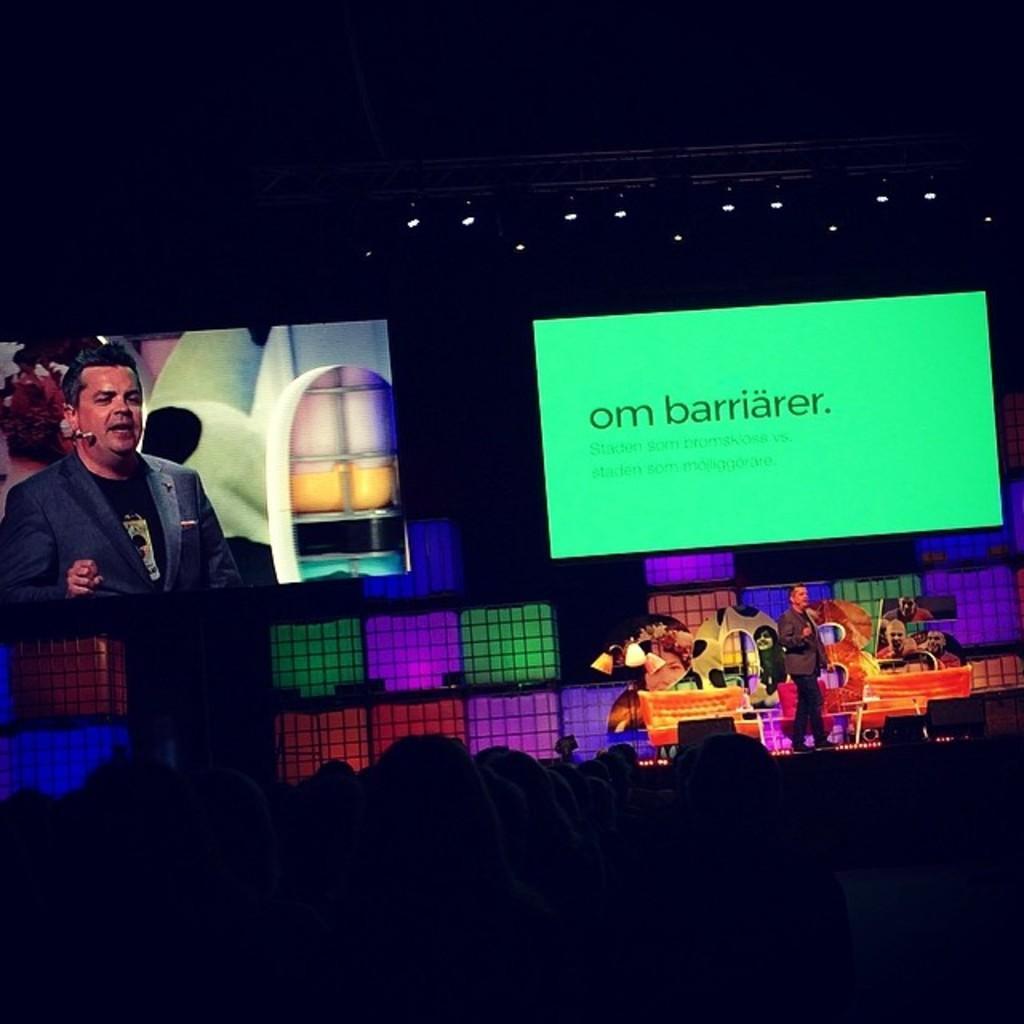Describe this image in one or two sentences. At the bottom the image is dark but we can see few persons. In the background there is a man standing on the stage,hoardings,screens,lights on the pole at the top and other objects. 